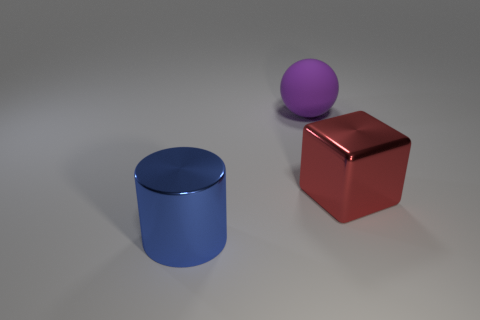What number of matte things are either blue things or small brown spheres?
Offer a terse response. 0. How many red things are there?
Your response must be concise. 1. What color is the shiny cylinder that is the same size as the rubber sphere?
Your answer should be compact. Blue. Do the rubber sphere and the metallic block have the same size?
Ensure brevity in your answer.  Yes. There is a red shiny thing; is its size the same as the blue cylinder that is in front of the red object?
Your response must be concise. Yes. What color is the object that is in front of the rubber sphere and behind the large blue object?
Give a very brief answer. Red. Are there more large red things that are in front of the large blue object than things that are to the left of the red shiny block?
Your answer should be compact. No. There is a blue object that is the same material as the block; what size is it?
Your response must be concise. Large. How many large metal objects are in front of the metal thing that is behind the cylinder?
Offer a very short reply. 1. Is there a tiny gray metal object of the same shape as the blue metallic thing?
Your answer should be compact. No. 